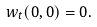Convert formula to latex. <formula><loc_0><loc_0><loc_500><loc_500>w _ { t } ( 0 , 0 ) = 0 .</formula> 